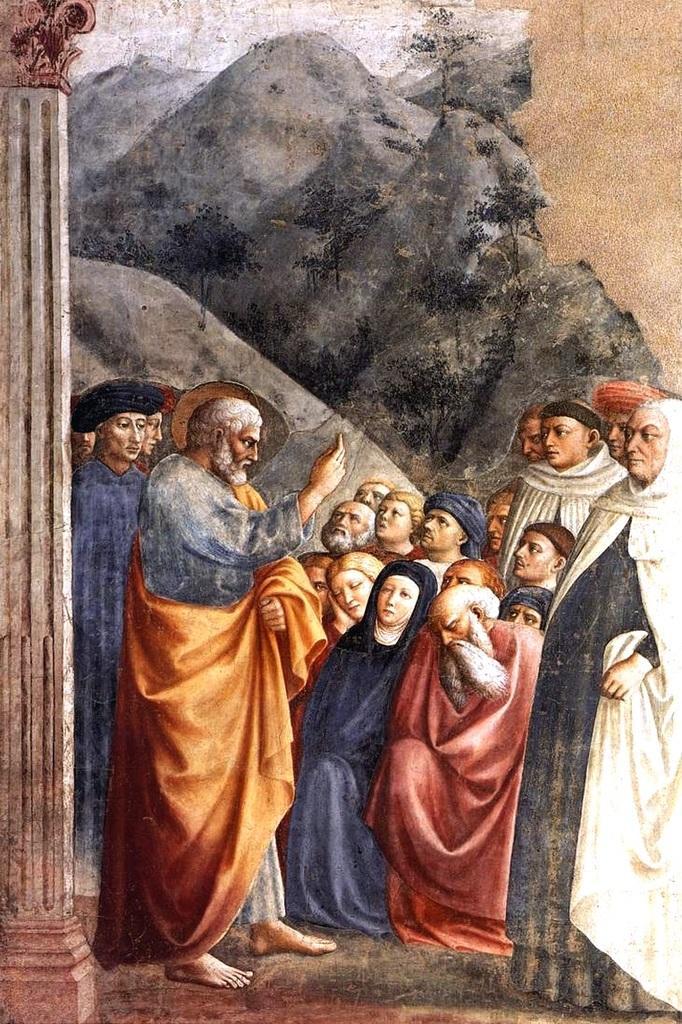Could you give a brief overview of what you see in this image? In this image we can see the painted picture. In this painted picture we can see the mountains, one white object at the top of the image, one pillar, few people are standing, few people are sitting, some trees on the mountains and one object on the top right side of the image. 